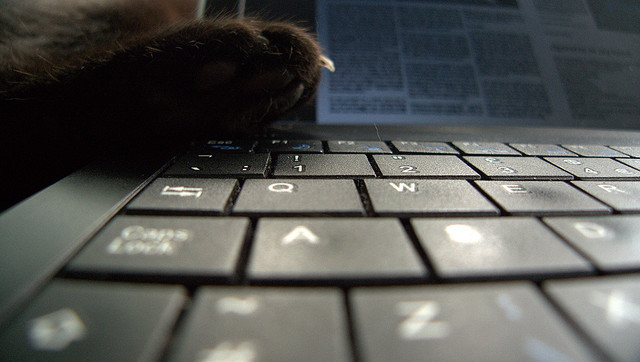Please transcribe the text information in this image. Q 1 W 2 A F3 F2 F1 R 4 3 E 